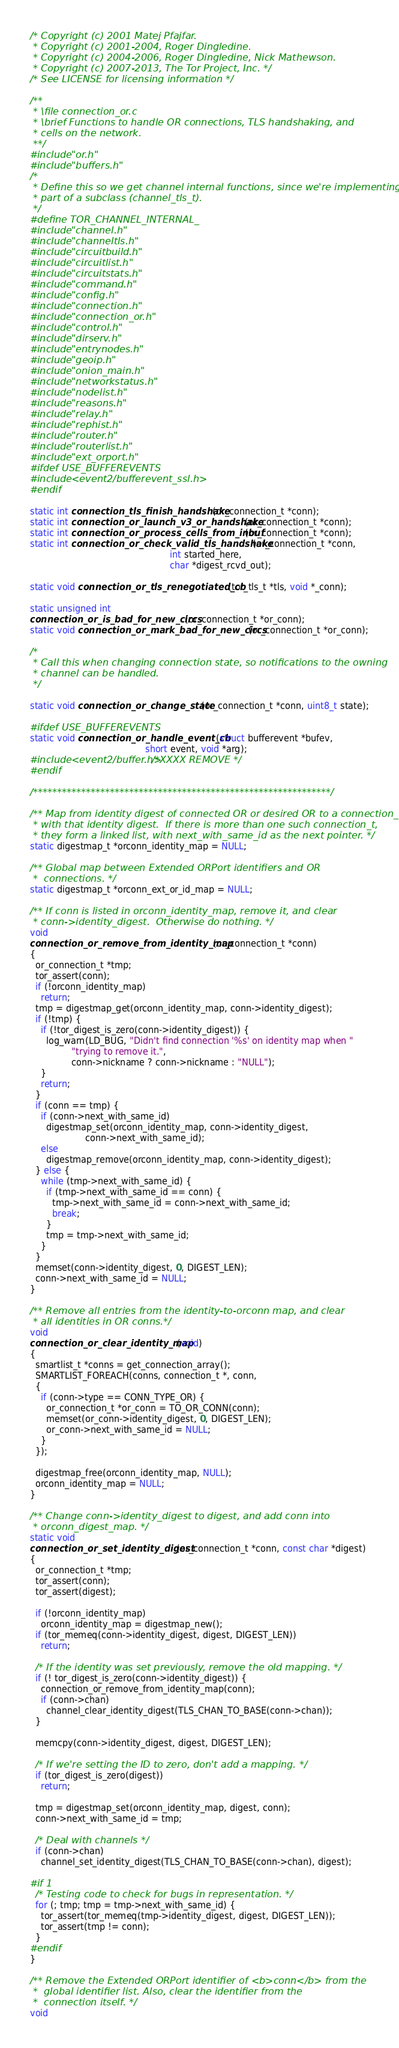<code> <loc_0><loc_0><loc_500><loc_500><_C_>/* Copyright (c) 2001 Matej Pfajfar.
 * Copyright (c) 2001-2004, Roger Dingledine.
 * Copyright (c) 2004-2006, Roger Dingledine, Nick Mathewson.
 * Copyright (c) 2007-2013, The Tor Project, Inc. */
/* See LICENSE for licensing information */

/**
 * \file connection_or.c
 * \brief Functions to handle OR connections, TLS handshaking, and
 * cells on the network.
 **/
#include "or.h"
#include "buffers.h"
/*
 * Define this so we get channel internal functions, since we're implementing
 * part of a subclass (channel_tls_t).
 */
#define TOR_CHANNEL_INTERNAL_
#include "channel.h"
#include "channeltls.h"
#include "circuitbuild.h"
#include "circuitlist.h"
#include "circuitstats.h"
#include "command.h"
#include "config.h"
#include "connection.h"
#include "connection_or.h"
#include "control.h"
#include "dirserv.h"
#include "entrynodes.h"
#include "geoip.h"
#include "onion_main.h"
#include "networkstatus.h"
#include "nodelist.h"
#include "reasons.h"
#include "relay.h"
#include "rephist.h"
#include "router.h"
#include "routerlist.h"
#include "ext_orport.h"
#ifdef USE_BUFFEREVENTS
#include <event2/bufferevent_ssl.h>
#endif

static int connection_tls_finish_handshake(or_connection_t *conn);
static int connection_or_launch_v3_or_handshake(or_connection_t *conn);
static int connection_or_process_cells_from_inbuf(or_connection_t *conn);
static int connection_or_check_valid_tls_handshake(or_connection_t *conn,
                                                   int started_here,
                                                   char *digest_rcvd_out);

static void connection_or_tls_renegotiated_cb(tor_tls_t *tls, void *_conn);

static unsigned int
connection_or_is_bad_for_new_circs(or_connection_t *or_conn);
static void connection_or_mark_bad_for_new_circs(or_connection_t *or_conn);

/*
 * Call this when changing connection state, so notifications to the owning
 * channel can be handled.
 */

static void connection_or_change_state(or_connection_t *conn, uint8_t state);

#ifdef USE_BUFFEREVENTS
static void connection_or_handle_event_cb(struct bufferevent *bufev,
                                          short event, void *arg);
#include <event2/buffer.h>/*XXXX REMOVE */
#endif

/**************************************************************/

/** Map from identity digest of connected OR or desired OR to a connection_t
 * with that identity digest.  If there is more than one such connection_t,
 * they form a linked list, with next_with_same_id as the next pointer. */
static digestmap_t *orconn_identity_map = NULL;

/** Global map between Extended ORPort identifiers and OR
 *  connections. */
static digestmap_t *orconn_ext_or_id_map = NULL;

/** If conn is listed in orconn_identity_map, remove it, and clear
 * conn->identity_digest.  Otherwise do nothing. */
void
connection_or_remove_from_identity_map(or_connection_t *conn)
{
  or_connection_t *tmp;
  tor_assert(conn);
  if (!orconn_identity_map)
    return;
  tmp = digestmap_get(orconn_identity_map, conn->identity_digest);
  if (!tmp) {
    if (!tor_digest_is_zero(conn->identity_digest)) {
      log_warn(LD_BUG, "Didn't find connection '%s' on identity map when "
               "trying to remove it.",
               conn->nickname ? conn->nickname : "NULL");
    }
    return;
  }
  if (conn == tmp) {
    if (conn->next_with_same_id)
      digestmap_set(orconn_identity_map, conn->identity_digest,
                    conn->next_with_same_id);
    else
      digestmap_remove(orconn_identity_map, conn->identity_digest);
  } else {
    while (tmp->next_with_same_id) {
      if (tmp->next_with_same_id == conn) {
        tmp->next_with_same_id = conn->next_with_same_id;
        break;
      }
      tmp = tmp->next_with_same_id;
    }
  }
  memset(conn->identity_digest, 0, DIGEST_LEN);
  conn->next_with_same_id = NULL;
}

/** Remove all entries from the identity-to-orconn map, and clear
 * all identities in OR conns.*/
void
connection_or_clear_identity_map(void)
{
  smartlist_t *conns = get_connection_array();
  SMARTLIST_FOREACH(conns, connection_t *, conn,
  {
    if (conn->type == CONN_TYPE_OR) {
      or_connection_t *or_conn = TO_OR_CONN(conn);
      memset(or_conn->identity_digest, 0, DIGEST_LEN);
      or_conn->next_with_same_id = NULL;
    }
  });

  digestmap_free(orconn_identity_map, NULL);
  orconn_identity_map = NULL;
}

/** Change conn->identity_digest to digest, and add conn into
 * orconn_digest_map. */
static void
connection_or_set_identity_digest(or_connection_t *conn, const char *digest)
{
  or_connection_t *tmp;
  tor_assert(conn);
  tor_assert(digest);

  if (!orconn_identity_map)
    orconn_identity_map = digestmap_new();
  if (tor_memeq(conn->identity_digest, digest, DIGEST_LEN))
    return;

  /* If the identity was set previously, remove the old mapping. */
  if (! tor_digest_is_zero(conn->identity_digest)) {
    connection_or_remove_from_identity_map(conn);
    if (conn->chan)
      channel_clear_identity_digest(TLS_CHAN_TO_BASE(conn->chan));
  }

  memcpy(conn->identity_digest, digest, DIGEST_LEN);

  /* If we're setting the ID to zero, don't add a mapping. */
  if (tor_digest_is_zero(digest))
    return;

  tmp = digestmap_set(orconn_identity_map, digest, conn);
  conn->next_with_same_id = tmp;

  /* Deal with channels */
  if (conn->chan)
    channel_set_identity_digest(TLS_CHAN_TO_BASE(conn->chan), digest);

#if 1
  /* Testing code to check for bugs in representation. */
  for (; tmp; tmp = tmp->next_with_same_id) {
    tor_assert(tor_memeq(tmp->identity_digest, digest, DIGEST_LEN));
    tor_assert(tmp != conn);
  }
#endif
}

/** Remove the Extended ORPort identifier of <b>conn</b> from the
 *  global identifier list. Also, clear the identifier from the
 *  connection itself. */
void</code> 